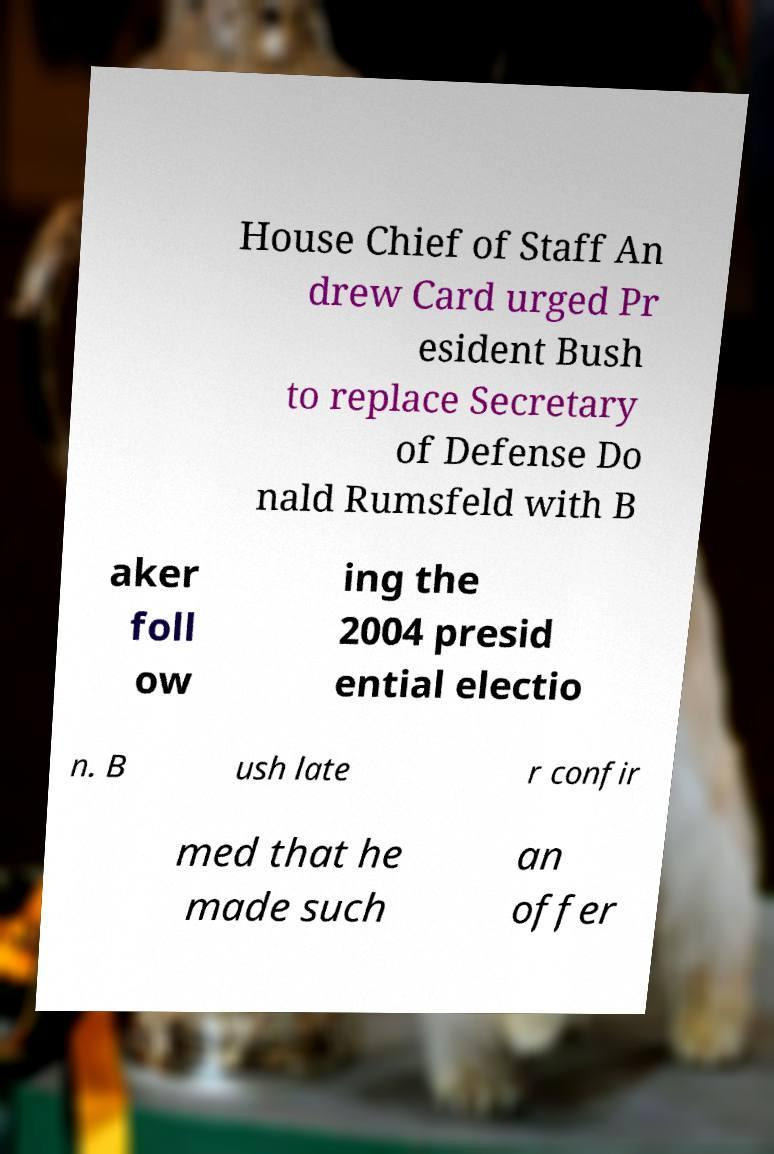For documentation purposes, I need the text within this image transcribed. Could you provide that? House Chief of Staff An drew Card urged Pr esident Bush to replace Secretary of Defense Do nald Rumsfeld with B aker foll ow ing the 2004 presid ential electio n. B ush late r confir med that he made such an offer 